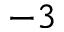<formula> <loc_0><loc_0><loc_500><loc_500>^ { - 3 }</formula> 